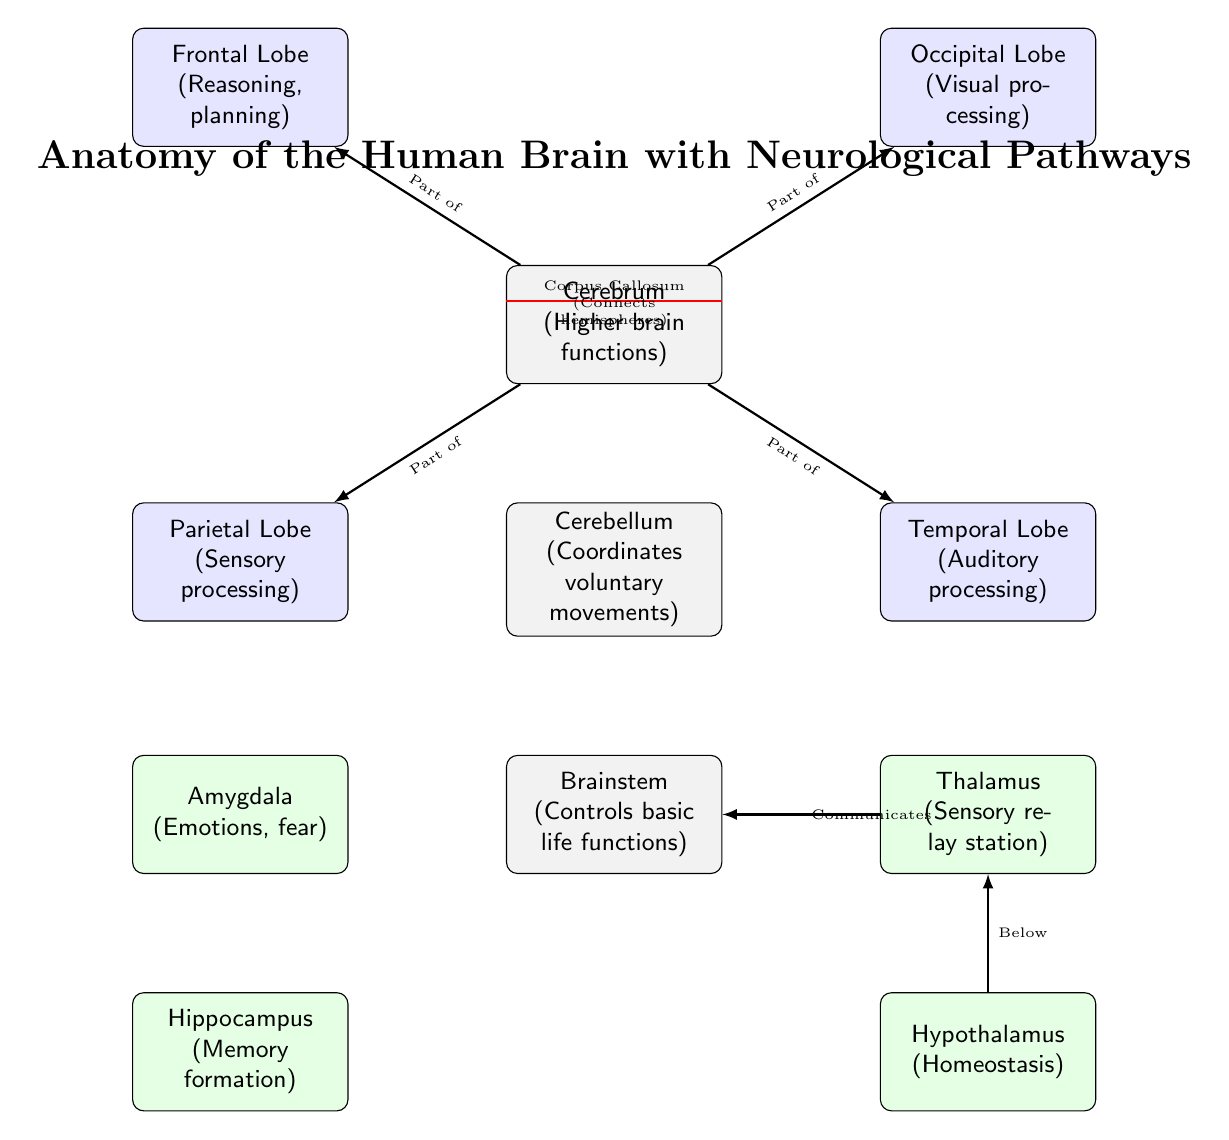What are the three main parts of the brain identified in the diagram? The diagram labels three main parts: the Cerebrum, Cerebellum, and Brainstem, which are clearly laid out vertically.
Answer: Cerebrum, Cerebellum, Brainstem What is the function associated with the Cerebellum? The diagram explicitly states that the Cerebellum coordinates voluntary movements, which is written under its label.
Answer: Coordinates voluntary movements How many lobes are directly connected to the Cerebrum? There are four lobes listed around the Cerebrum in the diagram: Frontal, Parietal, Occipital, and Temporal, counting them gives four.
Answer: Four What structure connects the two hemispheres of the brain? The red line in the diagram indicates the Corpus Callosum, which is labeled as connecting the hemispheres above the Cerebrum.
Answer: Corpus Callosum Which part of the brain processes sensory information and relays it? The Thalamus is identified as the sensory relay station in the diagram, as stated in its label.
Answer: Thalamus Which two parts of the brain are involved in memory and emotions? The diagram labels the Hippocampus for memory formation and the Amygdala for emotions, indicating their distinct functions.
Answer: Hippocampus, Amygdala How does the Thalamus relate to the Brainstem? The diagram shows a direct connection labeled "Communicates," indicating their relationship for sensory processing and life functions.
Answer: Communicates Where is the Hypothalamus located in relation to the Thalamus? The Hypothalamus is positioned directly below the Thalamus in the diagram, clearly indicated by their vertical arrangement.
Answer: Below What color represents the lobes in the diagram? The lobes are filled with blue color in the diagram, which distinguishes them from other parts of the brain shown with different colors.
Answer: Blue 